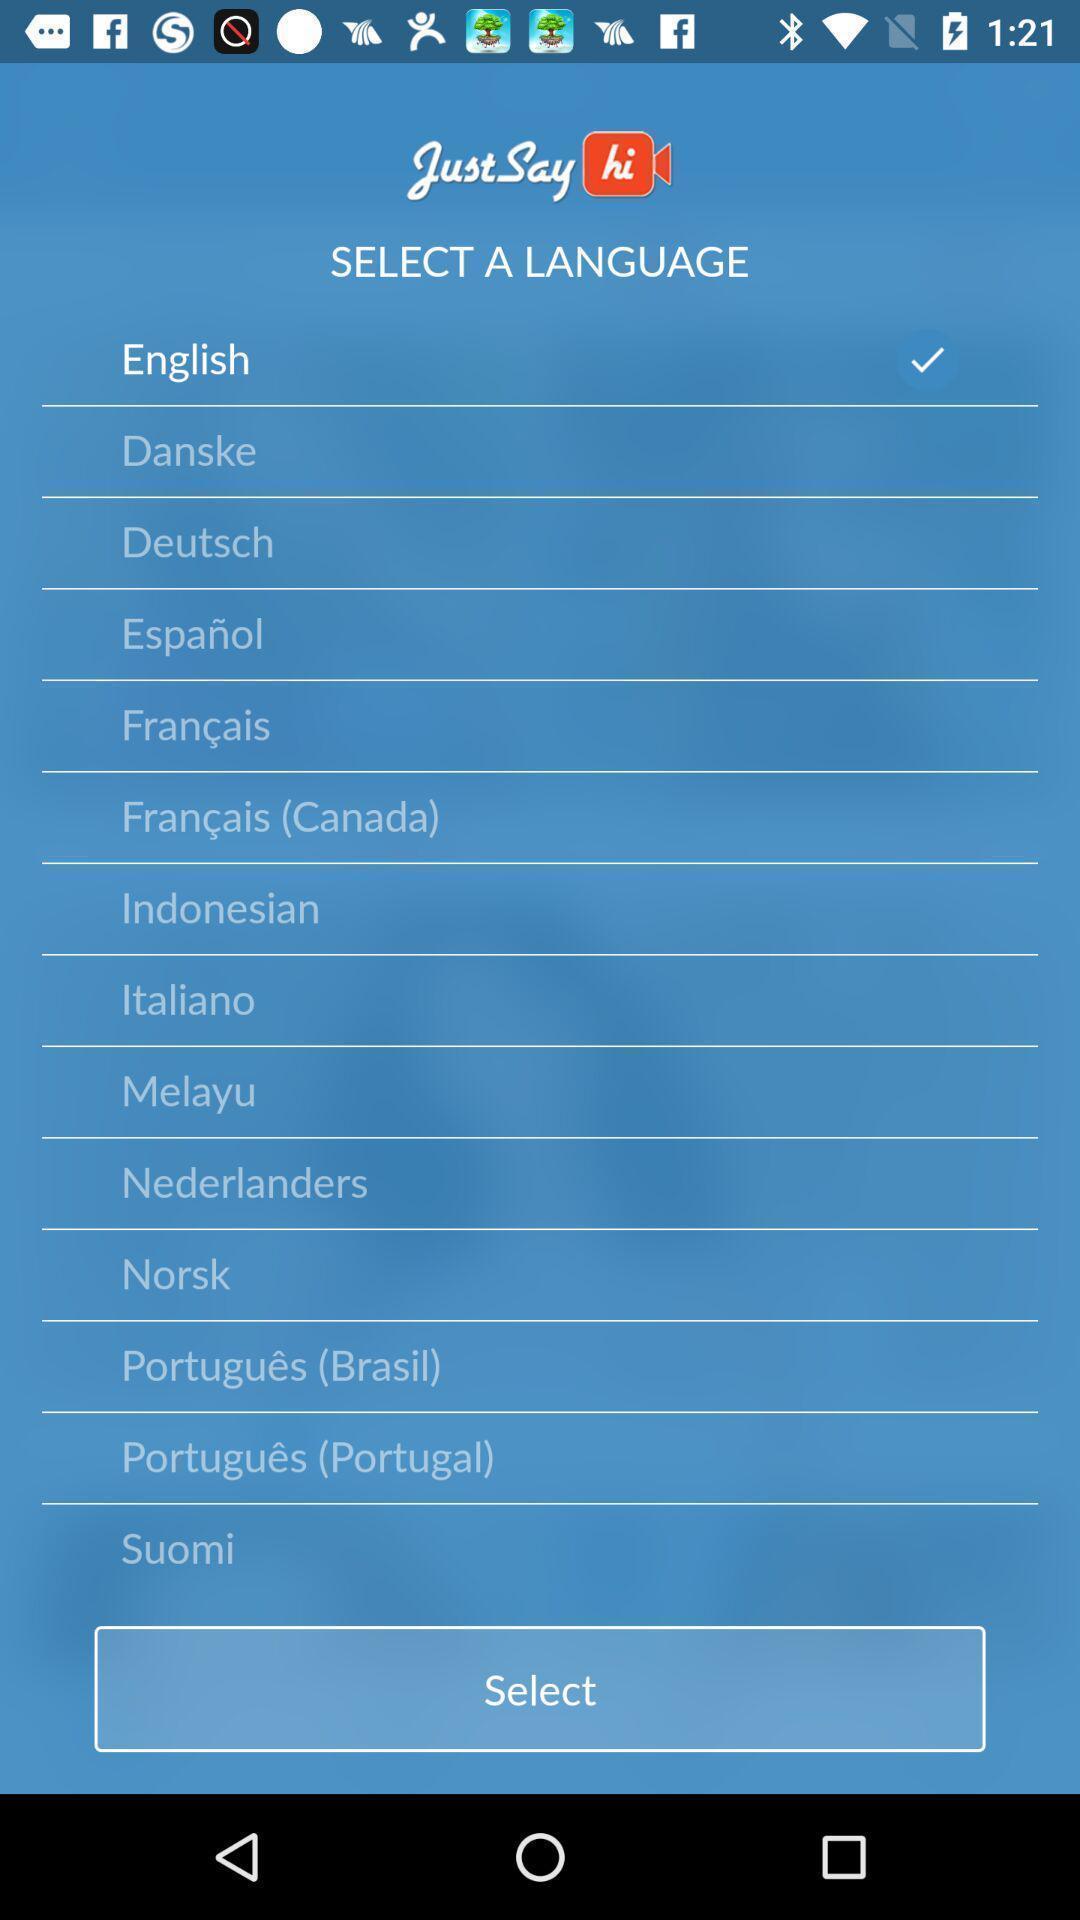Tell me what you see in this picture. Screen shows list of languages. 